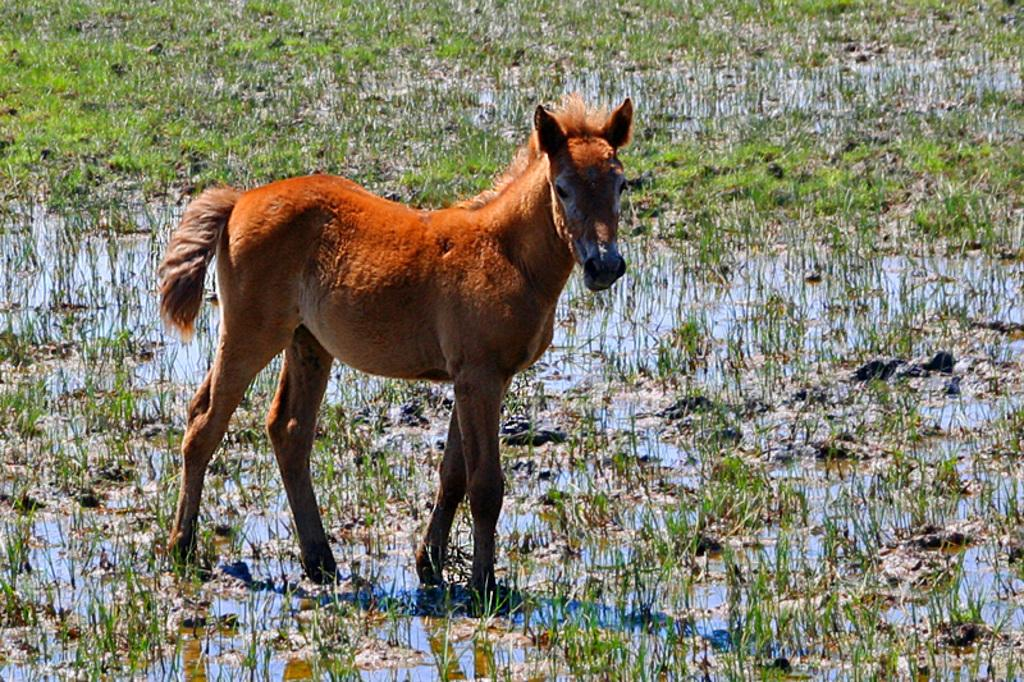What type of animal is in the image? There is a brown color horse in the image. How is the horse positioned in relation to other elements in the image? The horse is in front of other elements in the image. What type of vegetation is visible in the image? There is grass visible in the image. What is the condition of the grass in the image? The grass is partially submerged in water. What type of fruit can be seen floating in the water near the horse? There is no fruit visible in the image; it only features a brown color horse and grass partially submerged in water. 